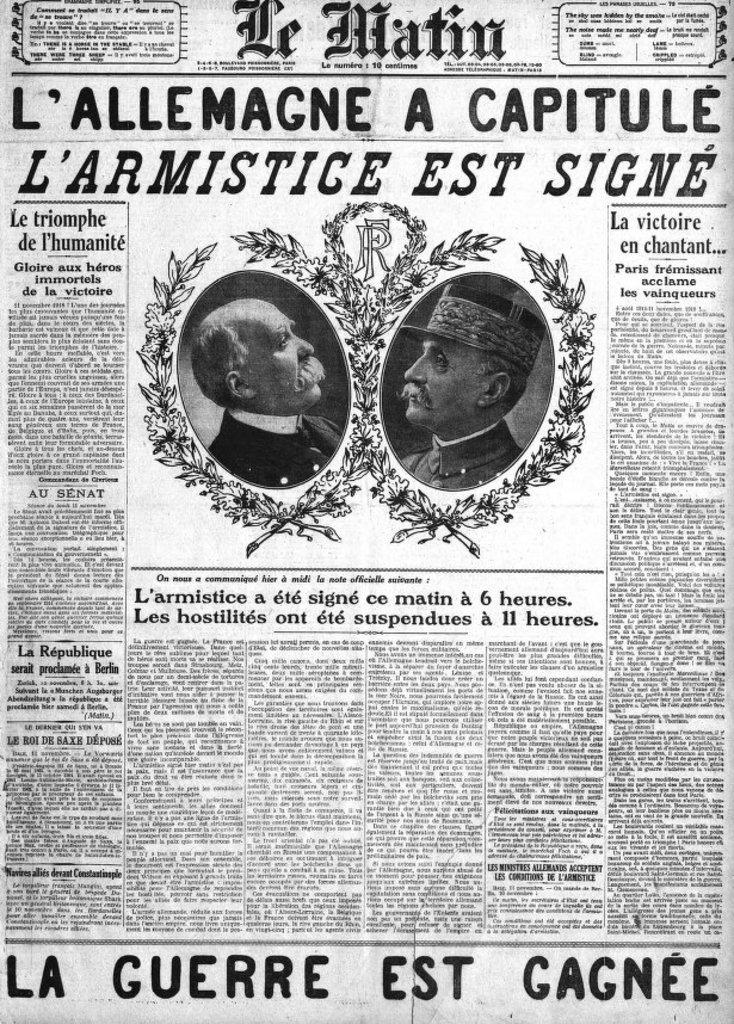What is the main object in the image? There is a newspaper in the image. What type of content is present in the newspaper? The newspaper contains text. Are there any images in the newspaper? Yes, there are human pictures in the newspaper. What type of hair can be seen on the toys in the image? There are no toys or hair present in the image; it only features a newspaper with text and human pictures. 